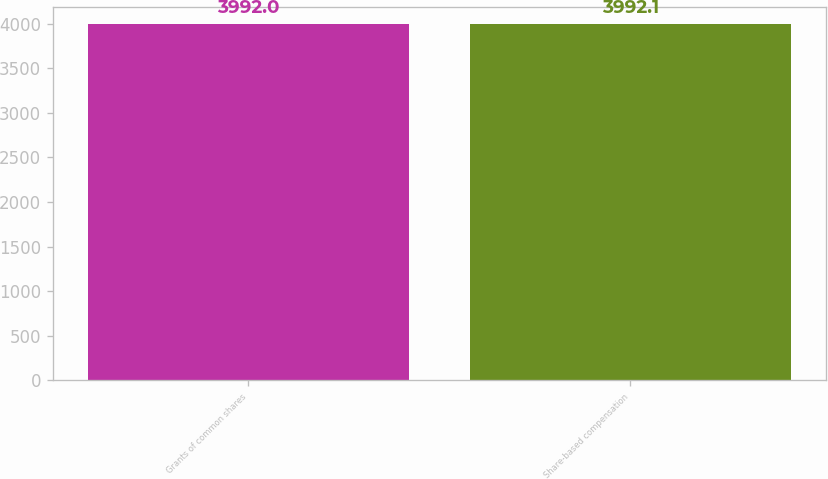Convert chart. <chart><loc_0><loc_0><loc_500><loc_500><bar_chart><fcel>Grants of common shares<fcel>Share-based compensation<nl><fcel>3992<fcel>3992.1<nl></chart> 